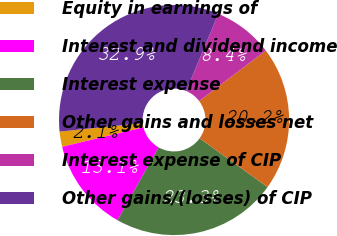<chart> <loc_0><loc_0><loc_500><loc_500><pie_chart><fcel>Equity in earnings of<fcel>Interest and dividend income<fcel>Interest expense<fcel>Other gains and losses net<fcel>Interest expense of CIP<fcel>Other gains/(losses) of CIP<nl><fcel>2.14%<fcel>13.08%<fcel>23.28%<fcel>20.21%<fcel>8.4%<fcel>32.89%<nl></chart> 